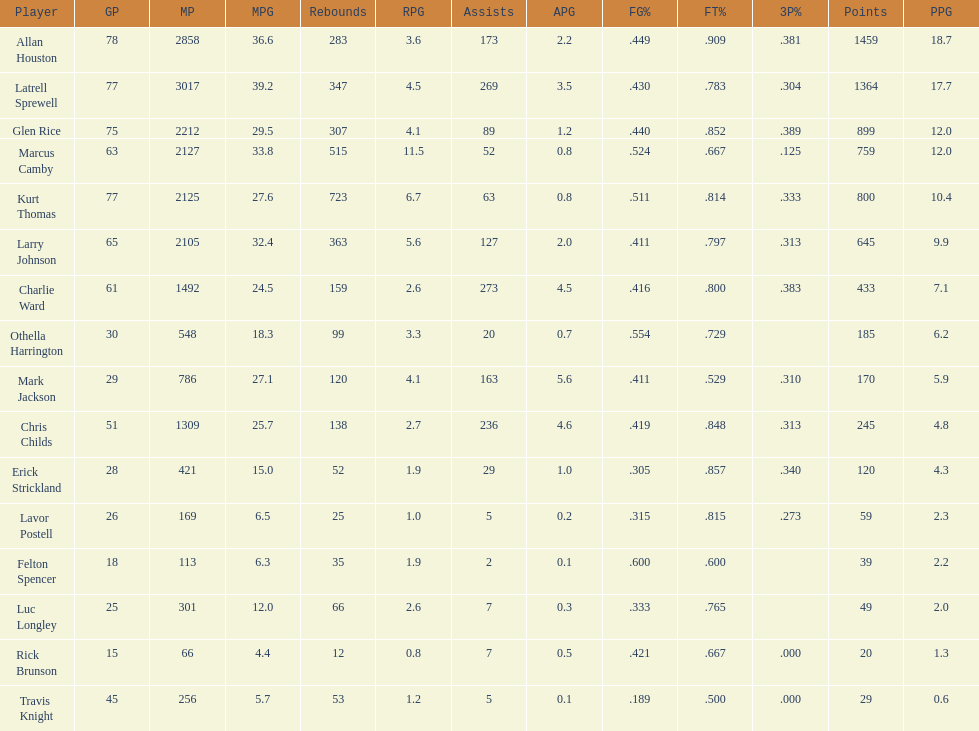How many more games did allan houston play than mark jackson? 49. Can you give me this table as a dict? {'header': ['Player', 'GP', 'MP', 'MPG', 'Rebounds', 'RPG', 'Assists', 'APG', 'FG%', 'FT%', '3P%', 'Points', 'PPG'], 'rows': [['Allan Houston', '78', '2858', '36.6', '283', '3.6', '173', '2.2', '.449', '.909', '.381', '1459', '18.7'], ['Latrell Sprewell', '77', '3017', '39.2', '347', '4.5', '269', '3.5', '.430', '.783', '.304', '1364', '17.7'], ['Glen Rice', '75', '2212', '29.5', '307', '4.1', '89', '1.2', '.440', '.852', '.389', '899', '12.0'], ['Marcus Camby', '63', '2127', '33.8', '515', '11.5', '52', '0.8', '.524', '.667', '.125', '759', '12.0'], ['Kurt Thomas', '77', '2125', '27.6', '723', '6.7', '63', '0.8', '.511', '.814', '.333', '800', '10.4'], ['Larry Johnson', '65', '2105', '32.4', '363', '5.6', '127', '2.0', '.411', '.797', '.313', '645', '9.9'], ['Charlie Ward', '61', '1492', '24.5', '159', '2.6', '273', '4.5', '.416', '.800', '.383', '433', '7.1'], ['Othella Harrington', '30', '548', '18.3', '99', '3.3', '20', '0.7', '.554', '.729', '', '185', '6.2'], ['Mark Jackson', '29', '786', '27.1', '120', '4.1', '163', '5.6', '.411', '.529', '.310', '170', '5.9'], ['Chris Childs', '51', '1309', '25.7', '138', '2.7', '236', '4.6', '.419', '.848', '.313', '245', '4.8'], ['Erick Strickland', '28', '421', '15.0', '52', '1.9', '29', '1.0', '.305', '.857', '.340', '120', '4.3'], ['Lavor Postell', '26', '169', '6.5', '25', '1.0', '5', '0.2', '.315', '.815', '.273', '59', '2.3'], ['Felton Spencer', '18', '113', '6.3', '35', '1.9', '2', '0.1', '.600', '.600', '', '39', '2.2'], ['Luc Longley', '25', '301', '12.0', '66', '2.6', '7', '0.3', '.333', '.765', '', '49', '2.0'], ['Rick Brunson', '15', '66', '4.4', '12', '0.8', '7', '0.5', '.421', '.667', '.000', '20', '1.3'], ['Travis Knight', '45', '256', '5.7', '53', '1.2', '5', '0.1', '.189', '.500', '.000', '29', '0.6']]} 